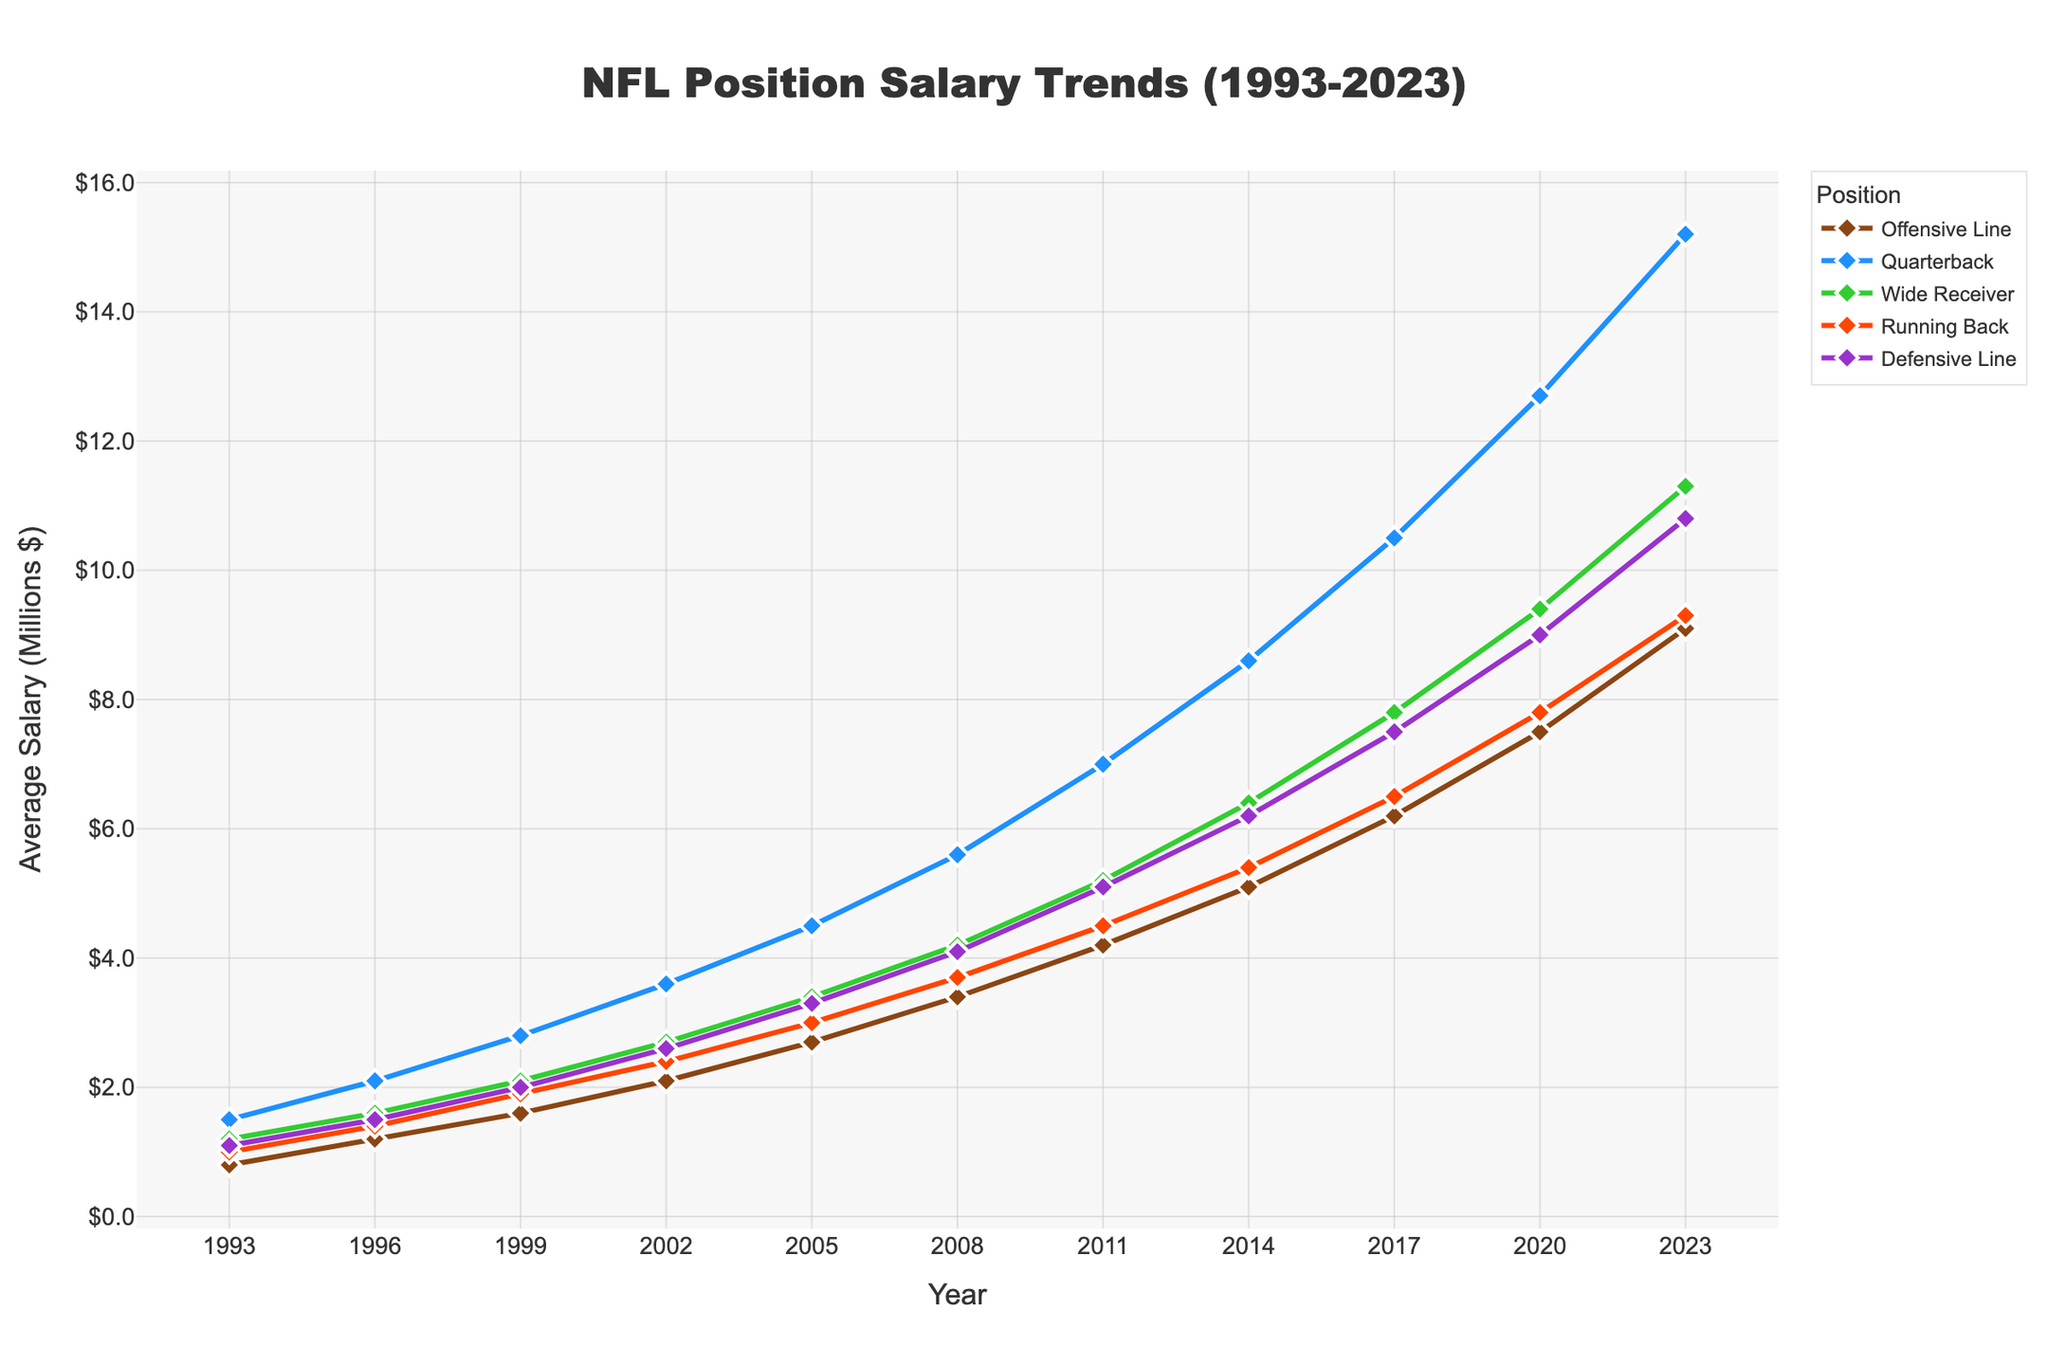Which position has the highest salary in 2023? According to the figure, the salary trend line that reaches the highest point in 2023 is for the quarterback position.
Answer: Quarterback What is the salary difference between an Offensive Line and a Quarterback in 2020? In 2020, the salary for the Offensive Line is $7.5 million, and for the Quarterback, it is $12.7 million. The difference is $12.7 million - $7.5 million.
Answer: $5.2 million How has the Defensive Line salary changed from 1993 to 2023? From the figure, the Defensive Line salary in 1993 is $1.1 million, and in 2023 it is $10.8 million. The change is $10.8 million - $1.1 million.
Answer: $9.7 million Which position had the highest salary growth between 1993 and 2023? To determine the highest growth, we compare the differences: Offensive Line ($9.1M-$0.8M), Quarterback ($15.2M-$1.5M), Wide Receiver ($11.3M-$1.2M), Running Back ($9.3M-$1.0M), and Defensive Line ($10.8M-$1.1M). The highest increase is for Quarterbacks.
Answer: Quarterback What is the average salary of Running Backs in 1993, 2003, and 2013? Average is calculated by summing the salaries in 1993 ($1.0M), 2003 (interpolated to be $2.15M), and 2013 (interpolated to be $5.45M), and dividing by 3.
Answer: $2.87 million In which year did the Wide Receiver salary first exceed $6 million? By observing the trend line for Wide Receivers, we see the salary first exceeds $6 million in 2014.
Answer: 2014 How much did the Offensive Line salary increase from 1996 to 1999? The figure shows the Offensive Line salary in 1996 is $1.2M and in 1999 it is $1.6M. The increase is $1.6M - $1.2M.
Answer: $0.4 million In which year did the average salary of Quarterbacks reach $10 million? Observing the trend line for Quarterbacks, it reaches $10 million in 2017.
Answer: 2017 Which position has the steepest increase in salary between 2011 and 2023? By examining the slope of the lines between 2011 and 2023, the Quarterback position shows the steepest increase.
Answer: Quarterback 